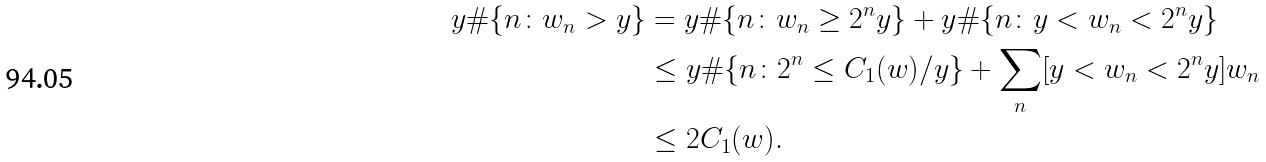<formula> <loc_0><loc_0><loc_500><loc_500>y \# \{ n \colon w _ { n } > y \} & = y \# \{ n \colon w _ { n } \geq 2 ^ { n } y \} + y \# \{ n \colon y < w _ { n } < 2 ^ { n } y \} \\ & \leq y \# \{ n \colon 2 ^ { n } \leq C _ { 1 } ( w ) / y \} + \sum _ { n } [ y < w _ { n } < 2 ^ { n } y ] w _ { n } \\ & \leq 2 C _ { 1 } ( w ) .</formula> 